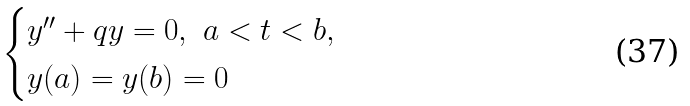Convert formula to latex. <formula><loc_0><loc_0><loc_500><loc_500>\begin{cases} y ^ { \prime \prime } + q y = 0 , \ a < t < b , \\ y ( a ) = y ( b ) = 0 \end{cases}</formula> 